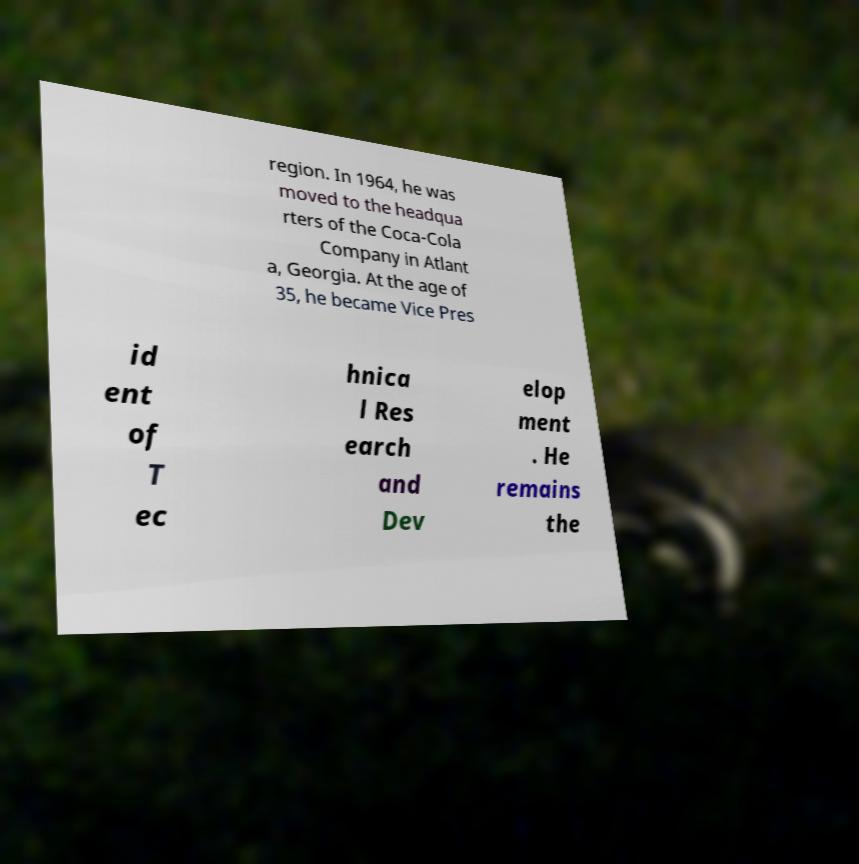Please read and relay the text visible in this image. What does it say? region. In 1964, he was moved to the headqua rters of the Coca-Cola Company in Atlant a, Georgia. At the age of 35, he became Vice Pres id ent of T ec hnica l Res earch and Dev elop ment . He remains the 